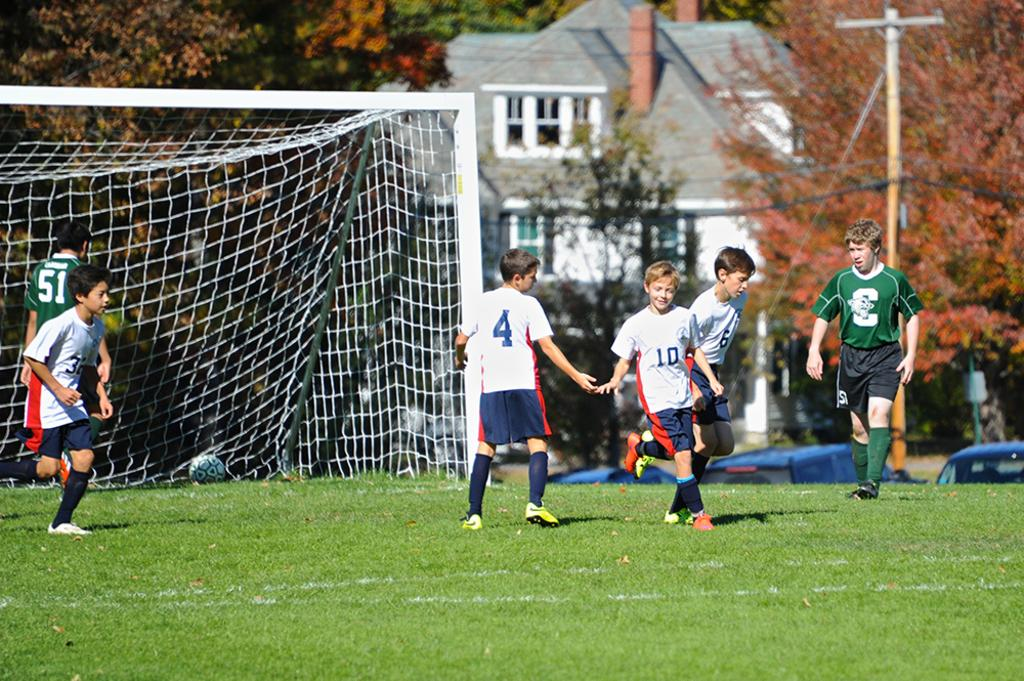What are the children doing in the image? The children are standing on the ground in the image. What sport-related object can be seen in the image? There is a sports netball in the image. What type of structures are visible in the image? There are buildings in the image. What type of street furniture is present in the image? There is a street pole in the image. What type of infrastructure is visible in the image? Cables are visible in the image. What type of vegetation is present in the image? Trees are present in the image. How many babies are crawling on the ground in the image? There are no babies present in the image; only children are visible. What word is written on the sports netball in the image? There is no word written on the sports netball in the image. 